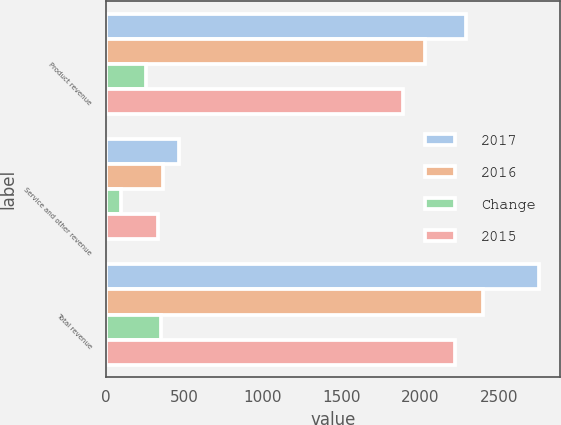<chart> <loc_0><loc_0><loc_500><loc_500><stacked_bar_chart><ecel><fcel>Product revenue<fcel>Service and other revenue<fcel>Total revenue<nl><fcel>2017<fcel>2289<fcel>463<fcel>2752<nl><fcel>2016<fcel>2032<fcel>366<fcel>2398<nl><fcel>Change<fcel>257<fcel>97<fcel>354<nl><fcel>2015<fcel>1891<fcel>329<fcel>2220<nl></chart> 